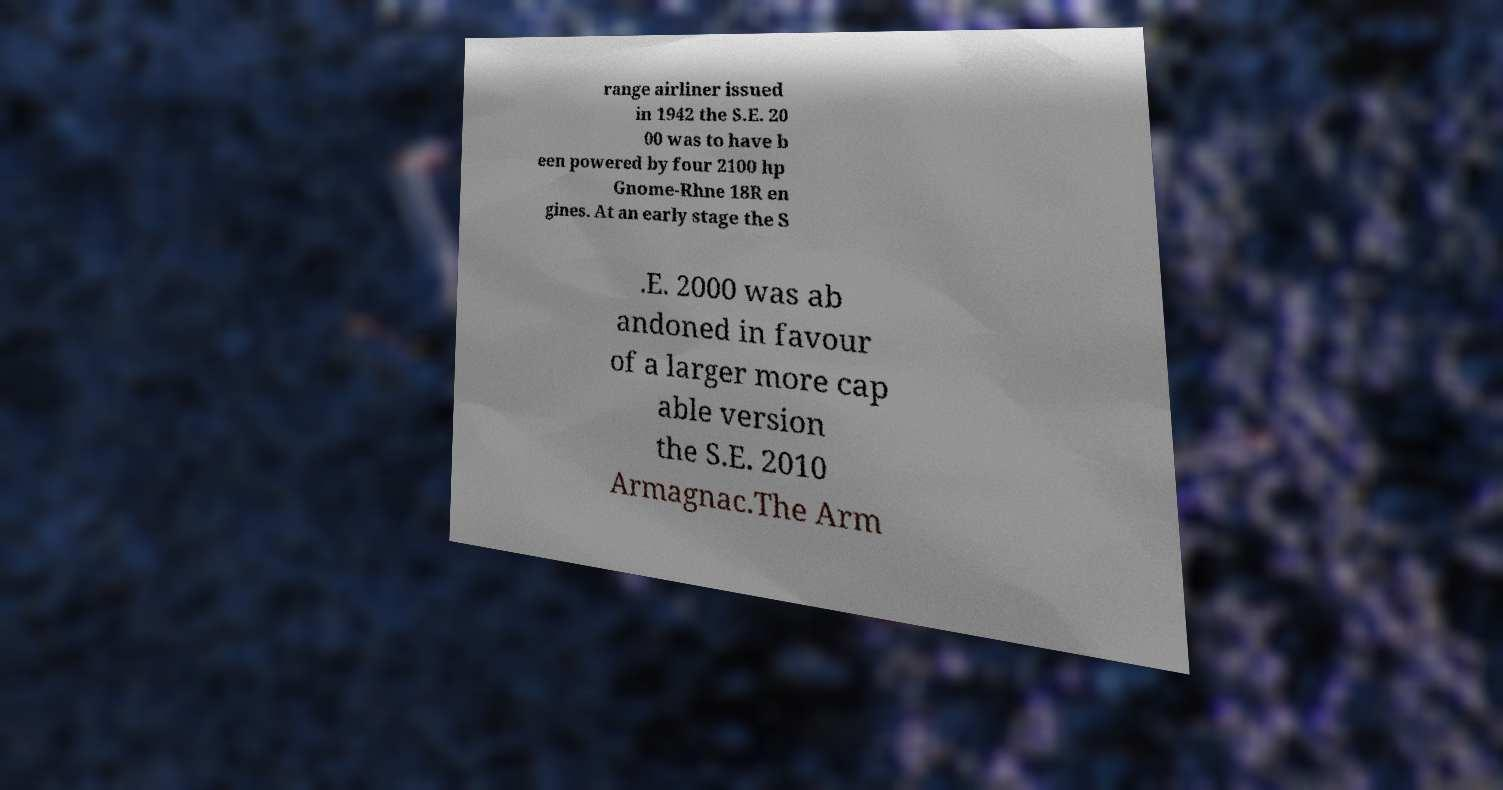There's text embedded in this image that I need extracted. Can you transcribe it verbatim? range airliner issued in 1942 the S.E. 20 00 was to have b een powered by four 2100 hp Gnome-Rhne 18R en gines. At an early stage the S .E. 2000 was ab andoned in favour of a larger more cap able version the S.E. 2010 Armagnac.The Arm 